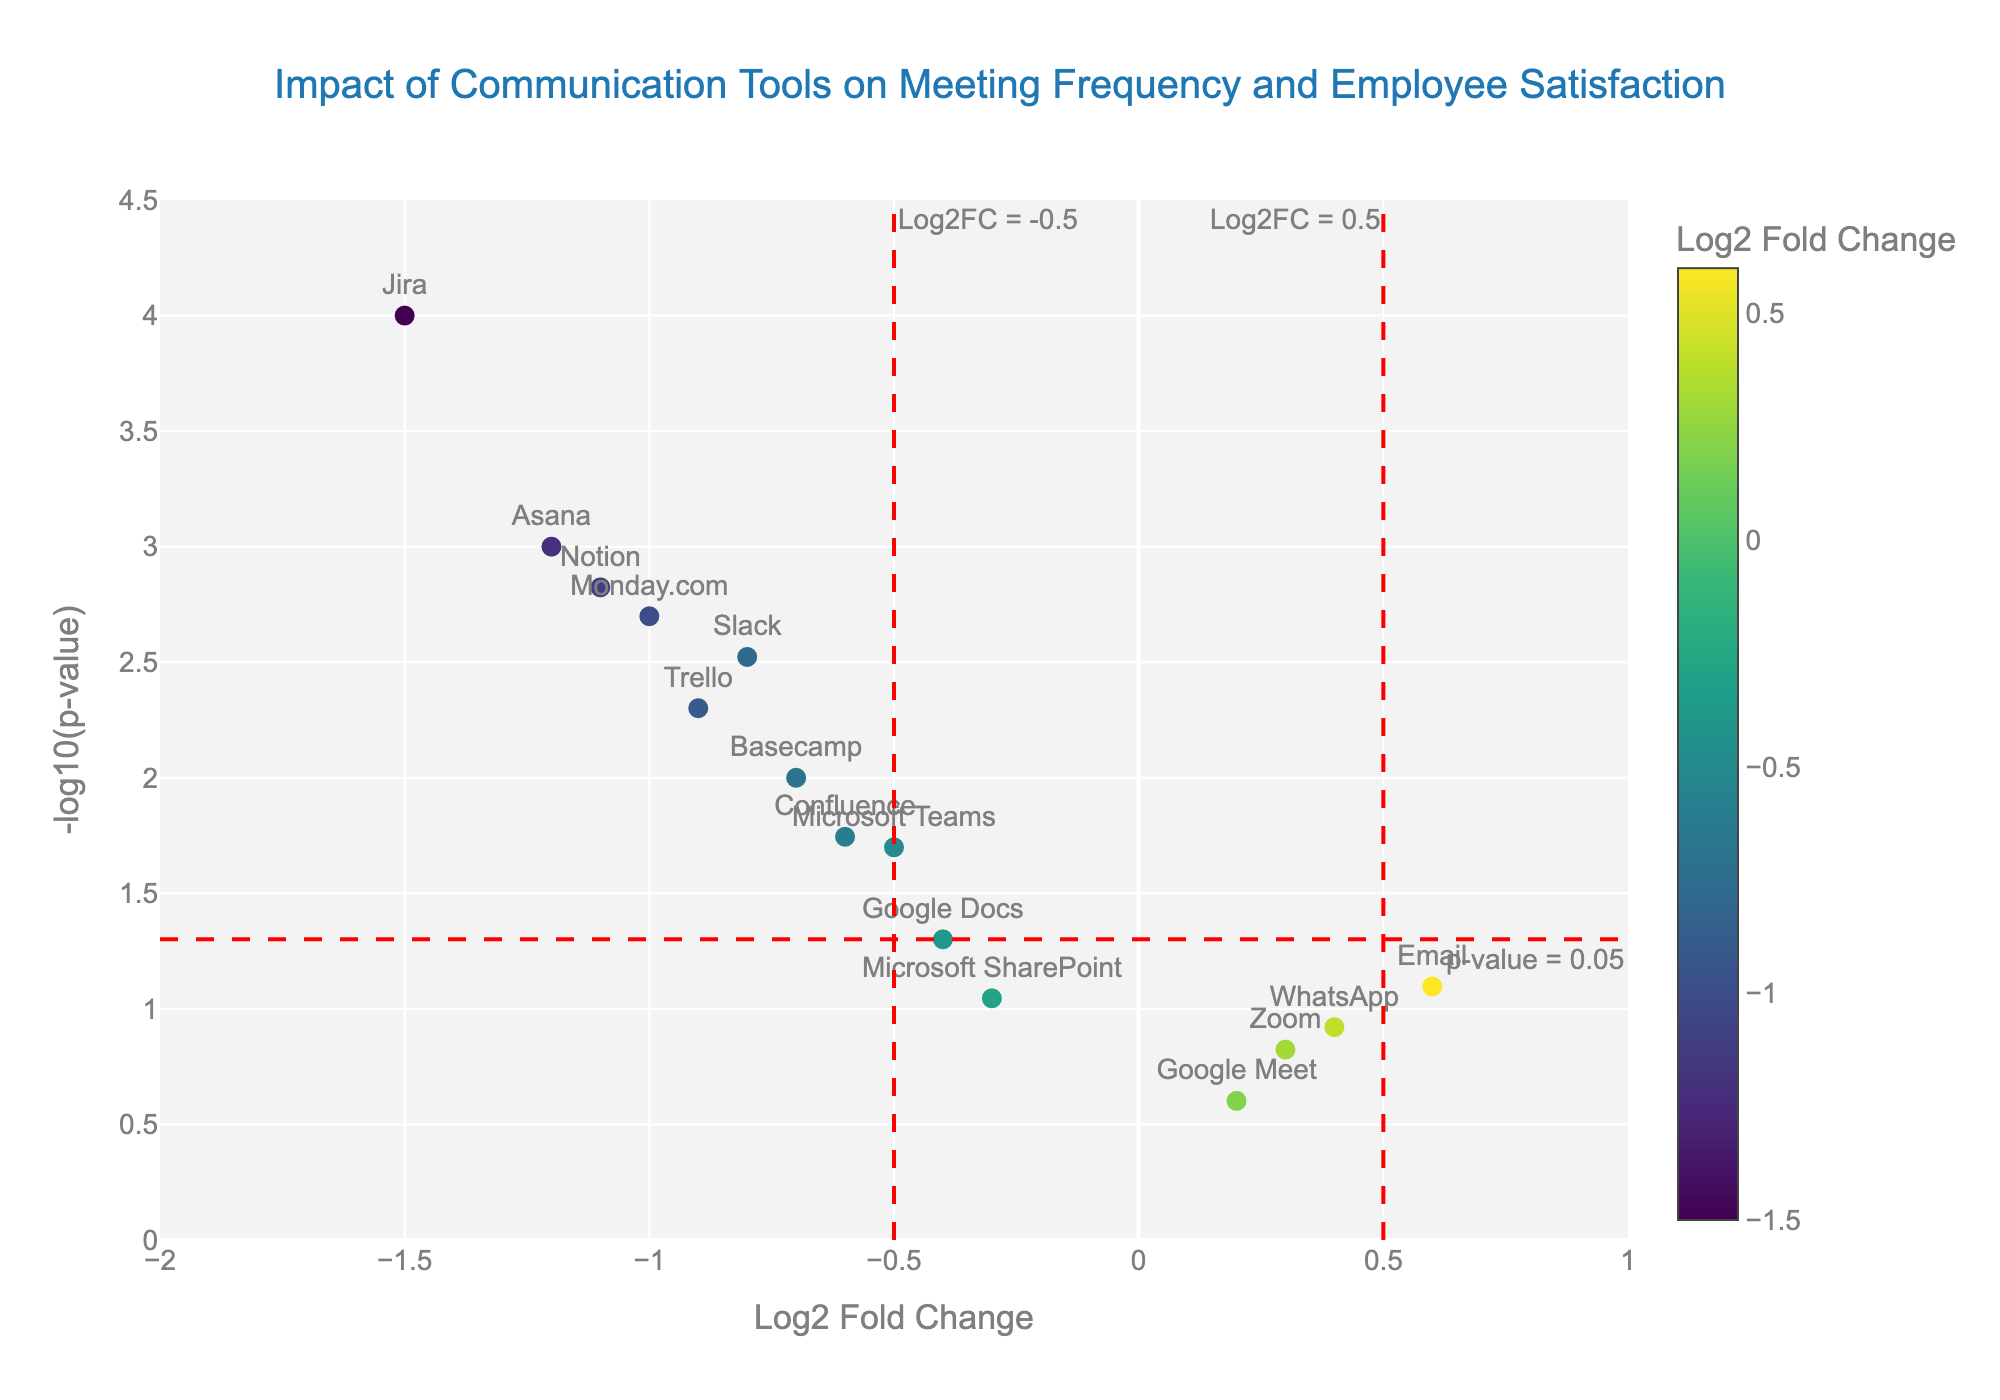What's the title of the plot? The title of the plot is prominently displayed on top of the figure. It helps quickly understand what the plot is about.
Answer: Impact of Communication Tools on Meeting Frequency and Employee Satisfaction How many tools have a Log2 Fold Change less than -1? By visually inspecting the x-axis (Log2 Fold Change) and identifying the markers to the left of -1, count the number of tools.
Answer: 4 Which tool has the highest -log10(p-value) and what is its value? Look for the data point that is the highest on the y-axis (-log10(p-value)) and read its label and y-axis value.
Answer: Jira, approximately 4 Are there any tools with a Log2 Fold Change between 0.5 and 1? Check the x-axis range between 0.5 and 1 to see if there are any data points within this interval.
Answer: No Which tools are below the p-value threshold of 0.05 and have a positive Log2 Fold Change? Identify the tools below the horizontal red dashed line at -log10(0.05), and of these, check which have a positive value on the x-axis.
Answer: WhatsApp and Email What color scale is used to represent the Log2 Fold Change values? The legend on the figure indicates the color scale applied to Log2 Fold Change values.
Answer: Viridis What's the Log2 Fold Change value for Slack, and is it significant? Hover text or label near Slack marker shows its Log2 Fold Change, while its y-position shows its significance compared to the -log10(p-value) threshold line.
Answer: -0.8, Yes Compare the Log2 Fold Change and significance of Asana and Trello. Which one has a more significant impact based on p-value? Check both the x-axis (Log2FC) and y-axis (-log10(p-value)) for Asana and Trello. Compare their -log10(p-value) values to determine significance.
Answer: Asana, with a lower p-value How does Google Meet compare to Microsoft Teams in terms of Log2 Fold Change and p-value? Check positions of both tools on the x-axis (Log2FC) and y-axis (-log10(p-value)), and compare both values.
Answer: Google Meet has a higher Log2FC (0.2 vs -0.5), but lower significance (higher p-value) Which tool has the most negative impact on meeting frequency and employee satisfaction? The tool with the lowest Log2 Fold Change value has the most negative impact.
Answer: Jira 